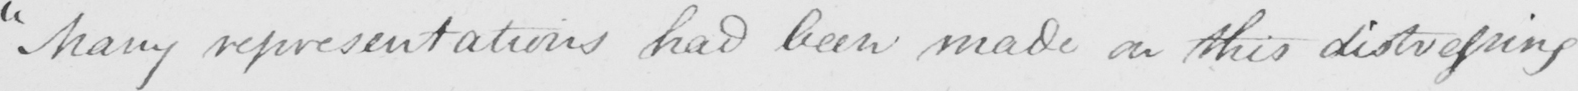Please transcribe the handwritten text in this image. " Many representations had been made on this distressing 